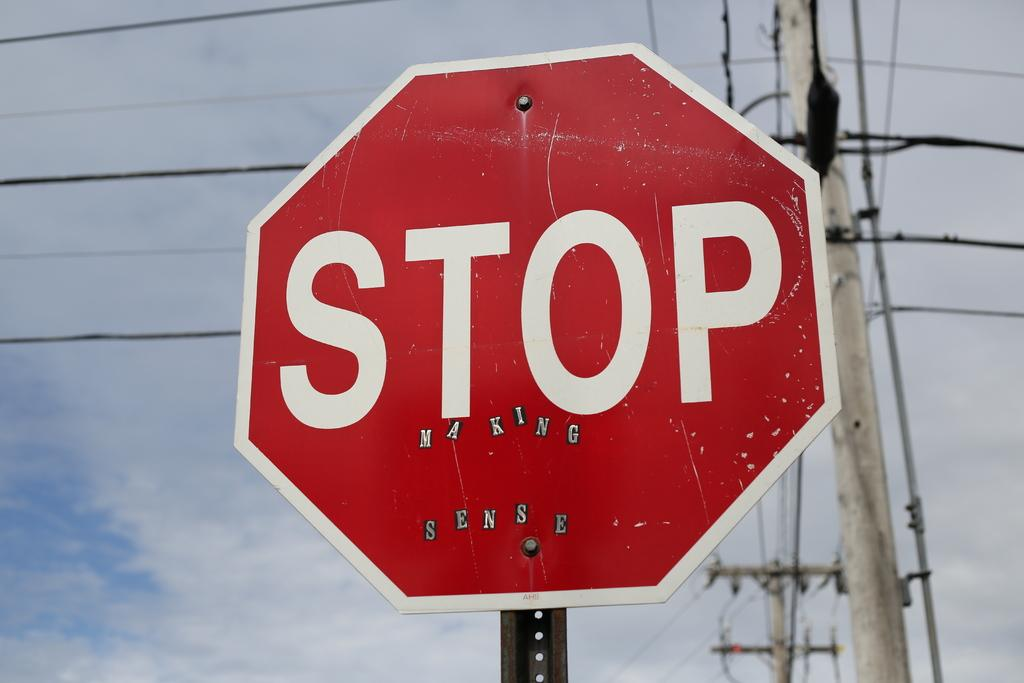Provide a one-sentence caption for the provided image. Someone has added stickers to a stop sign so it says "stop making sense". 